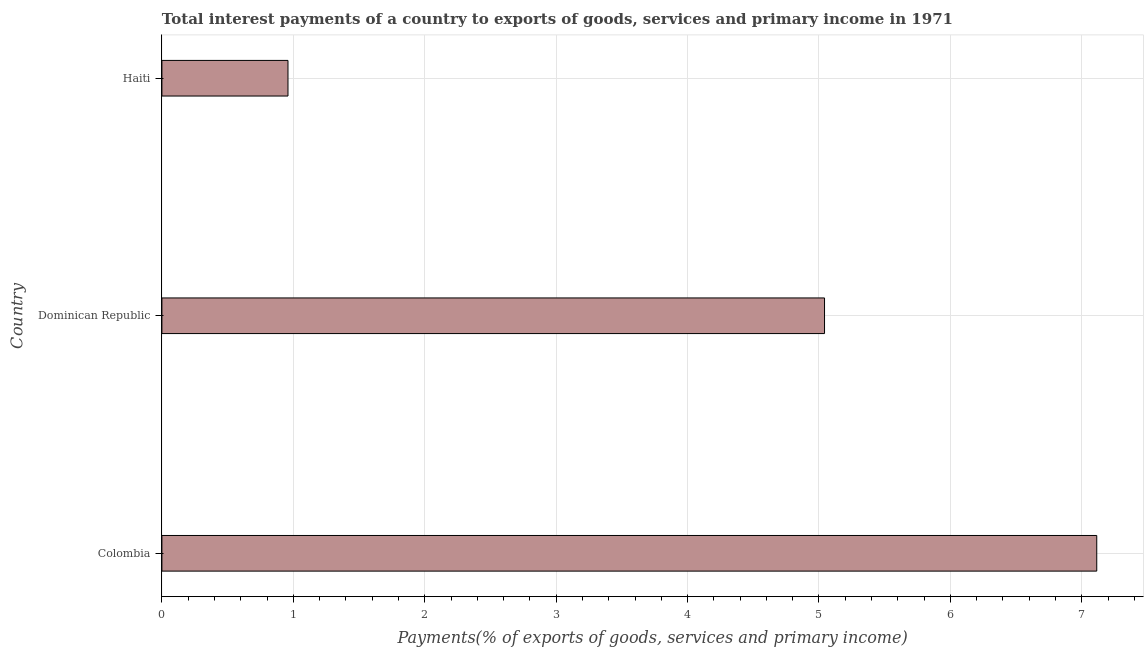Does the graph contain grids?
Provide a short and direct response. Yes. What is the title of the graph?
Your response must be concise. Total interest payments of a country to exports of goods, services and primary income in 1971. What is the label or title of the X-axis?
Your response must be concise. Payments(% of exports of goods, services and primary income). What is the label or title of the Y-axis?
Keep it short and to the point. Country. What is the total interest payments on external debt in Dominican Republic?
Your answer should be very brief. 5.04. Across all countries, what is the maximum total interest payments on external debt?
Offer a very short reply. 7.11. Across all countries, what is the minimum total interest payments on external debt?
Your answer should be compact. 0.96. In which country was the total interest payments on external debt maximum?
Make the answer very short. Colombia. In which country was the total interest payments on external debt minimum?
Give a very brief answer. Haiti. What is the sum of the total interest payments on external debt?
Make the answer very short. 13.12. What is the difference between the total interest payments on external debt in Dominican Republic and Haiti?
Your response must be concise. 4.08. What is the average total interest payments on external debt per country?
Ensure brevity in your answer.  4.37. What is the median total interest payments on external debt?
Your answer should be compact. 5.04. What is the ratio of the total interest payments on external debt in Colombia to that in Dominican Republic?
Your answer should be compact. 1.41. Is the total interest payments on external debt in Dominican Republic less than that in Haiti?
Your answer should be compact. No. What is the difference between the highest and the second highest total interest payments on external debt?
Provide a succinct answer. 2.07. Is the sum of the total interest payments on external debt in Colombia and Dominican Republic greater than the maximum total interest payments on external debt across all countries?
Offer a very short reply. Yes. What is the difference between the highest and the lowest total interest payments on external debt?
Give a very brief answer. 6.15. In how many countries, is the total interest payments on external debt greater than the average total interest payments on external debt taken over all countries?
Offer a very short reply. 2. How many bars are there?
Your answer should be very brief. 3. How many countries are there in the graph?
Provide a short and direct response. 3. What is the difference between two consecutive major ticks on the X-axis?
Your answer should be very brief. 1. What is the Payments(% of exports of goods, services and primary income) in Colombia?
Ensure brevity in your answer.  7.11. What is the Payments(% of exports of goods, services and primary income) in Dominican Republic?
Offer a very short reply. 5.04. What is the Payments(% of exports of goods, services and primary income) in Haiti?
Provide a short and direct response. 0.96. What is the difference between the Payments(% of exports of goods, services and primary income) in Colombia and Dominican Republic?
Your answer should be very brief. 2.07. What is the difference between the Payments(% of exports of goods, services and primary income) in Colombia and Haiti?
Your response must be concise. 6.15. What is the difference between the Payments(% of exports of goods, services and primary income) in Dominican Republic and Haiti?
Your answer should be very brief. 4.08. What is the ratio of the Payments(% of exports of goods, services and primary income) in Colombia to that in Dominican Republic?
Provide a succinct answer. 1.41. What is the ratio of the Payments(% of exports of goods, services and primary income) in Colombia to that in Haiti?
Your response must be concise. 7.41. What is the ratio of the Payments(% of exports of goods, services and primary income) in Dominican Republic to that in Haiti?
Provide a short and direct response. 5.25. 